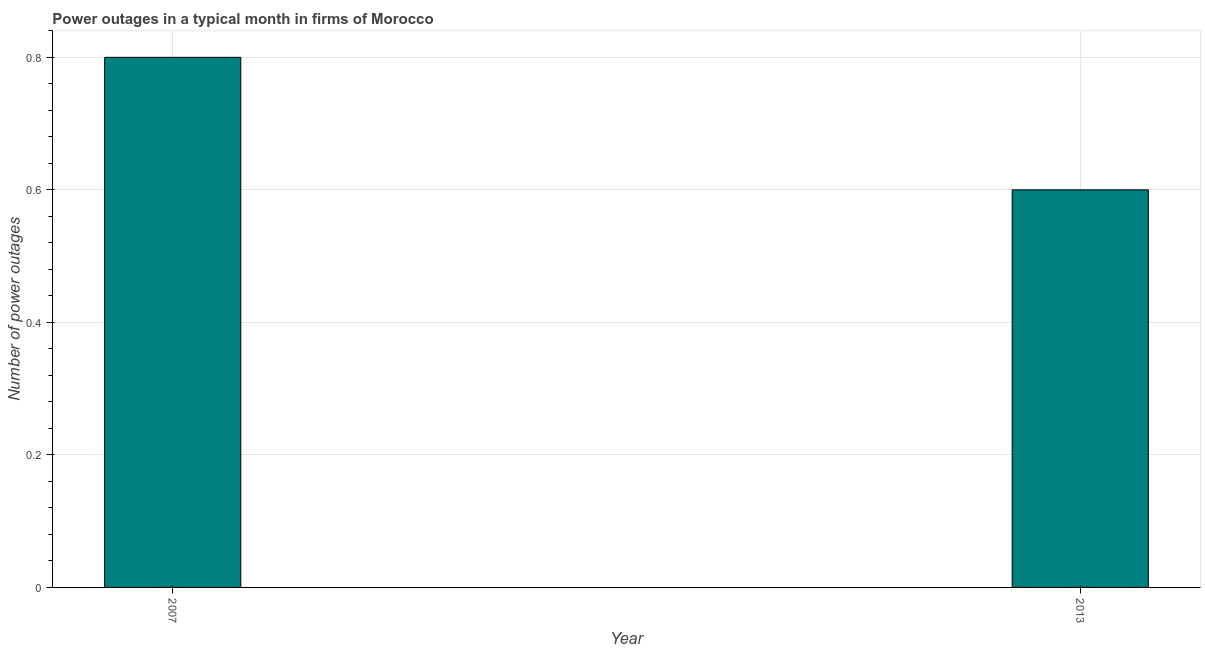Does the graph contain any zero values?
Ensure brevity in your answer.  No. Does the graph contain grids?
Ensure brevity in your answer.  Yes. What is the title of the graph?
Keep it short and to the point. Power outages in a typical month in firms of Morocco. What is the label or title of the Y-axis?
Make the answer very short. Number of power outages. What is the number of power outages in 2013?
Ensure brevity in your answer.  0.6. What is the sum of the number of power outages?
Provide a short and direct response. 1.4. What is the median number of power outages?
Offer a terse response. 0.7. Do a majority of the years between 2007 and 2013 (inclusive) have number of power outages greater than 0.6 ?
Offer a terse response. No. What is the ratio of the number of power outages in 2007 to that in 2013?
Your response must be concise. 1.33. Is the number of power outages in 2007 less than that in 2013?
Your response must be concise. No. How many bars are there?
Make the answer very short. 2. Are all the bars in the graph horizontal?
Offer a very short reply. No. What is the difference between the Number of power outages in 2007 and 2013?
Offer a terse response. 0.2. What is the ratio of the Number of power outages in 2007 to that in 2013?
Your answer should be very brief. 1.33. 